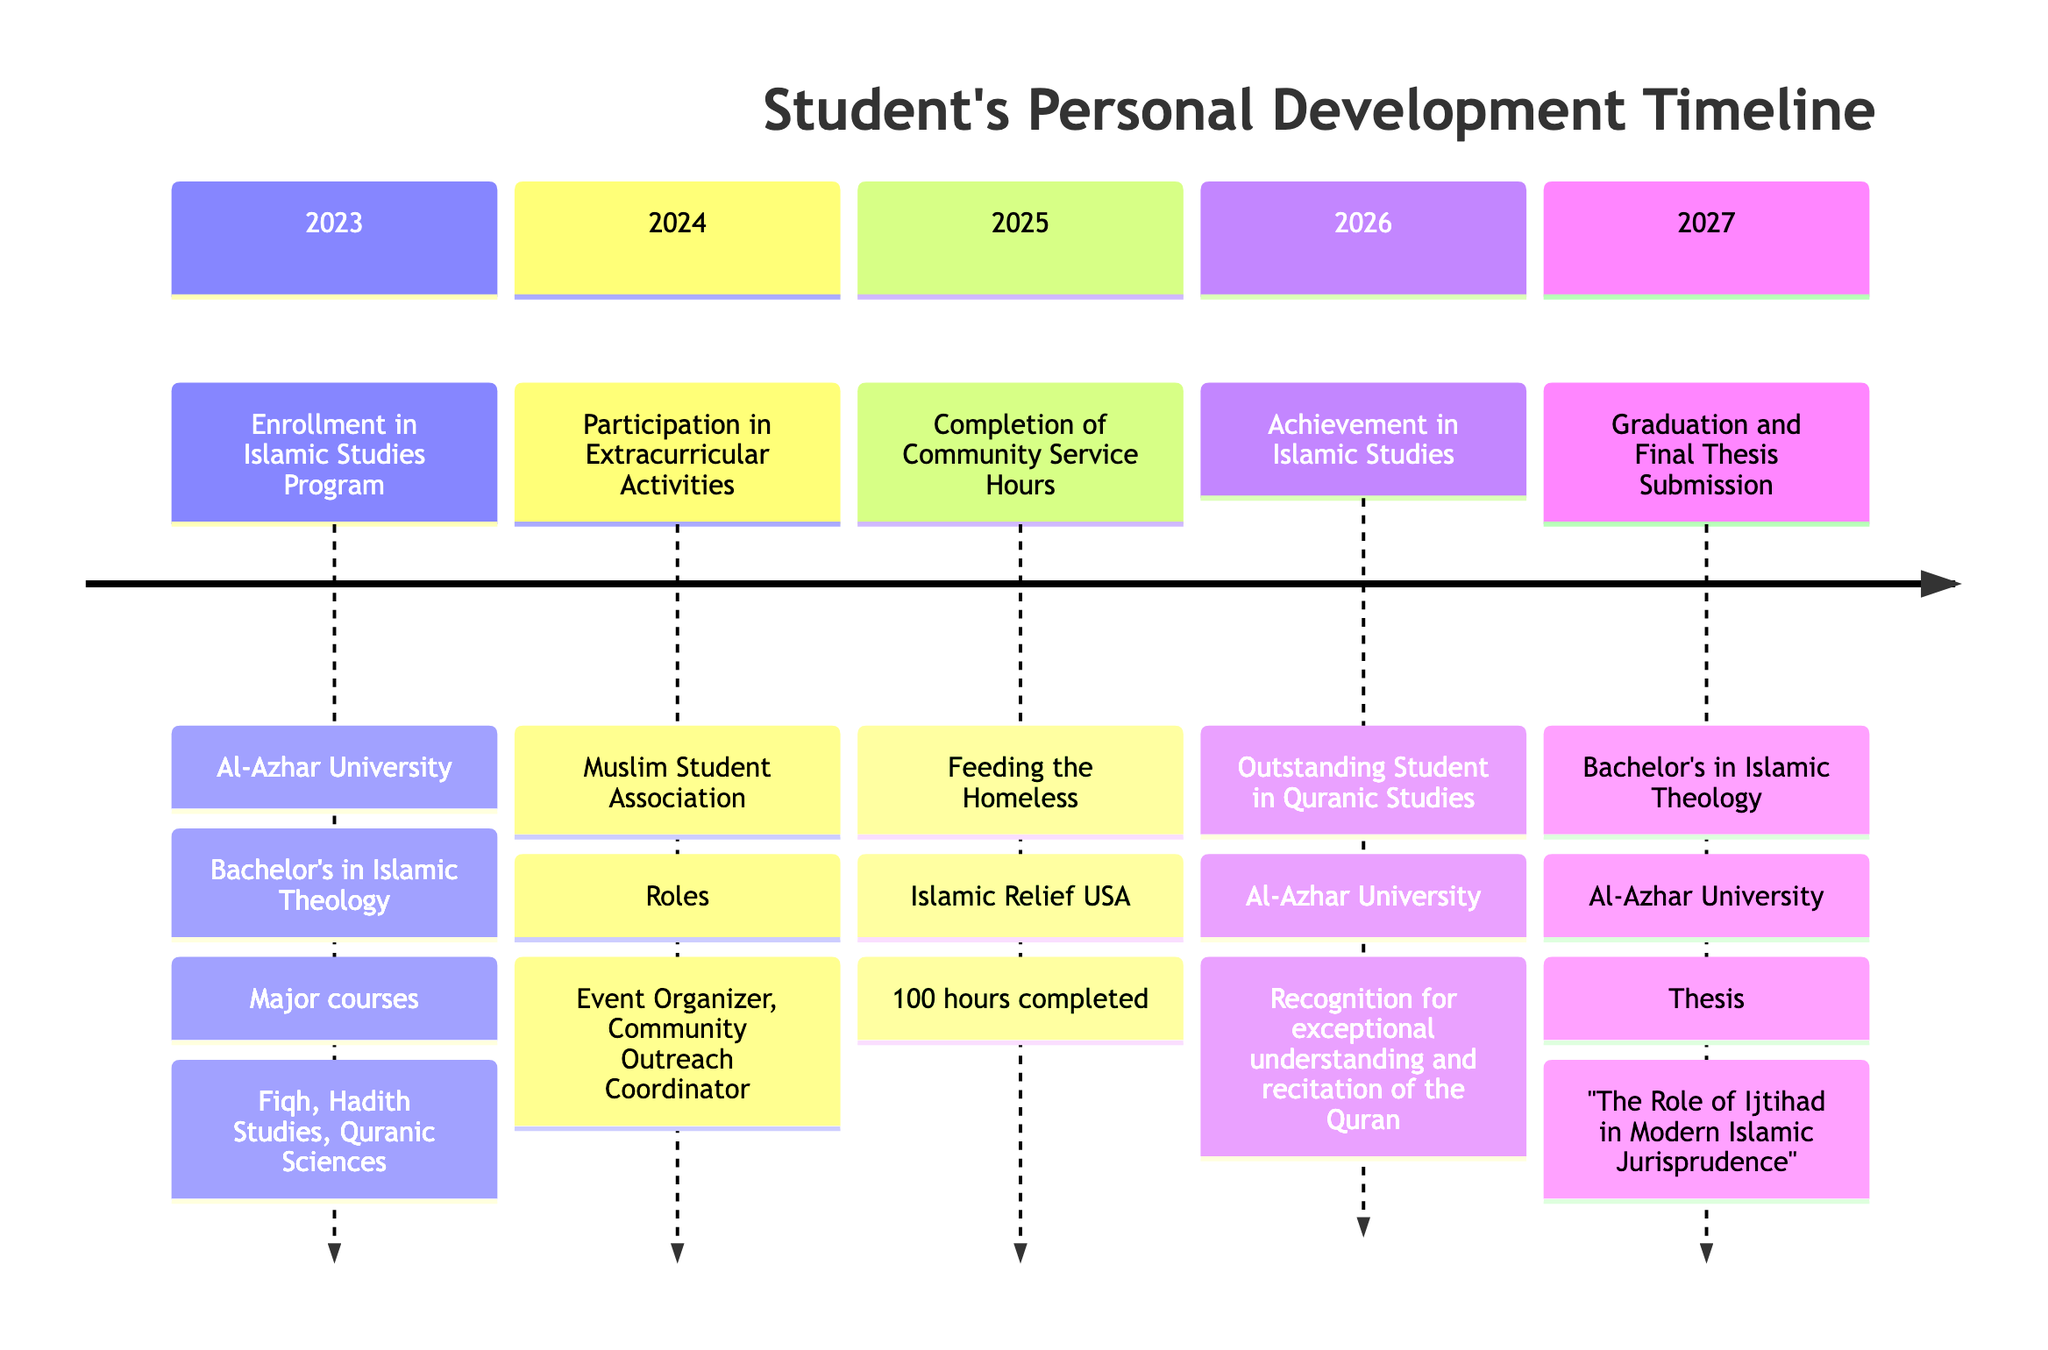What year did the student enroll in the Islamic Studies Program? The timeline lists "2023" as the year of enrollment in the Islamic Studies Program.
Answer: 2023 What institution is the student attending for their Bachelor's degree? According to the timeline, the institution is "Al-Azhar University" where the student is enrolled in the Bachelor's in Islamic Theology program.
Answer: Al-Azhar University How many hours of community service did the student complete? The timeline states that the student completed "100" hours of community service as part of the Feeding the Homeless program.
Answer: 100 What was the title of the student's final thesis? The timeline specifies the thesis title as "The Role of Ijtihad in Modern Islamic Jurisprudence" submitted upon graduation.
Answer: The Role of Ijtihad in Modern Islamic Jurisprudence In which year did the student achieve recognition in Islamic Studies? The timeline shows that the achievement in Islamic Studies occurred in "2026" when the student received recognition for outstanding work in Quranic Studies.
Answer: 2026 What roles did the student undertake in the Muslim Student Association? The student's roles included "Event Organizer" and "Community Outreach Coordinator" as detailed in the 2024 section of the timeline.
Answer: Event Organizer, Community Outreach Coordinator Which service program did the student participate in for community service? The timeline specifies that the student participated in the "Feeding the Homeless" service program organized by Islamic Relief USA.
Answer: Feeding the Homeless What notable award did the student receive in 2026? The timeline indicates that the student received the award "Outstanding Student in Quranic Studies" as recognition for exceptional understanding.
Answer: Outstanding Student in Quranic Studies Which major courses are listed for the Bachelor's in Islamic Theology? The major courses listed are "Fiqh," "Hadith Studies," and "Quranic Sciences" as part of the program at Al-Azhar University.
Answer: Fiqh, Hadith Studies, Quranic Sciences 